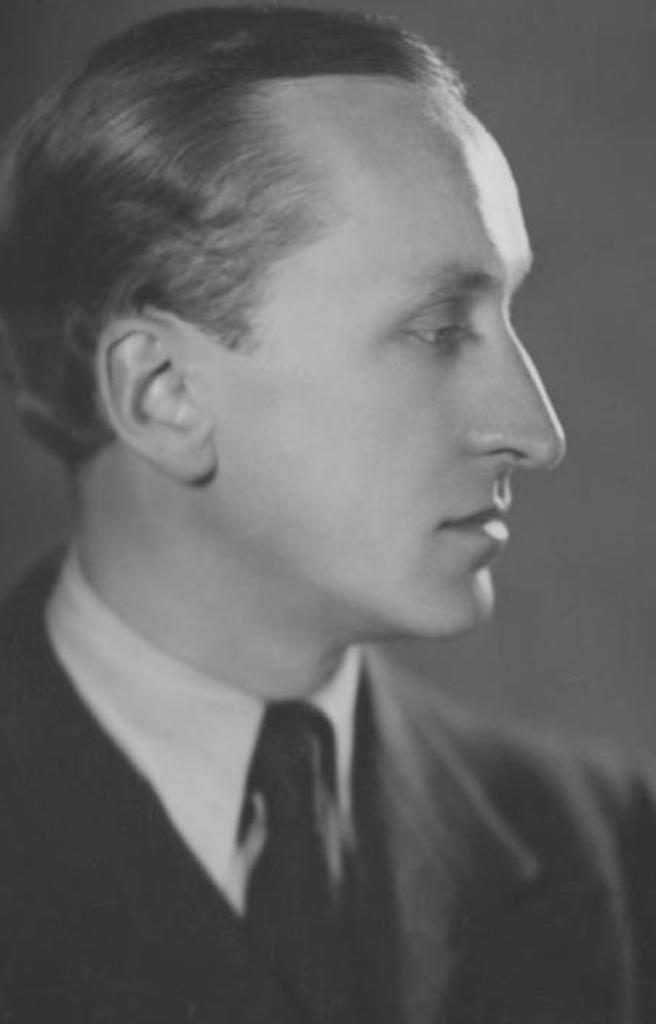What is the color scheme of the image? The image is black and white. Can you describe the person in the image? There is a person in the image. What type of clothing is the person wearing? The person is wearing a coat and a tie. What type of zephyr can be seen in the image? There is no zephyr present in the image. Can you tell me how many donkeys are in the image? There are no donkeys present in the image. 